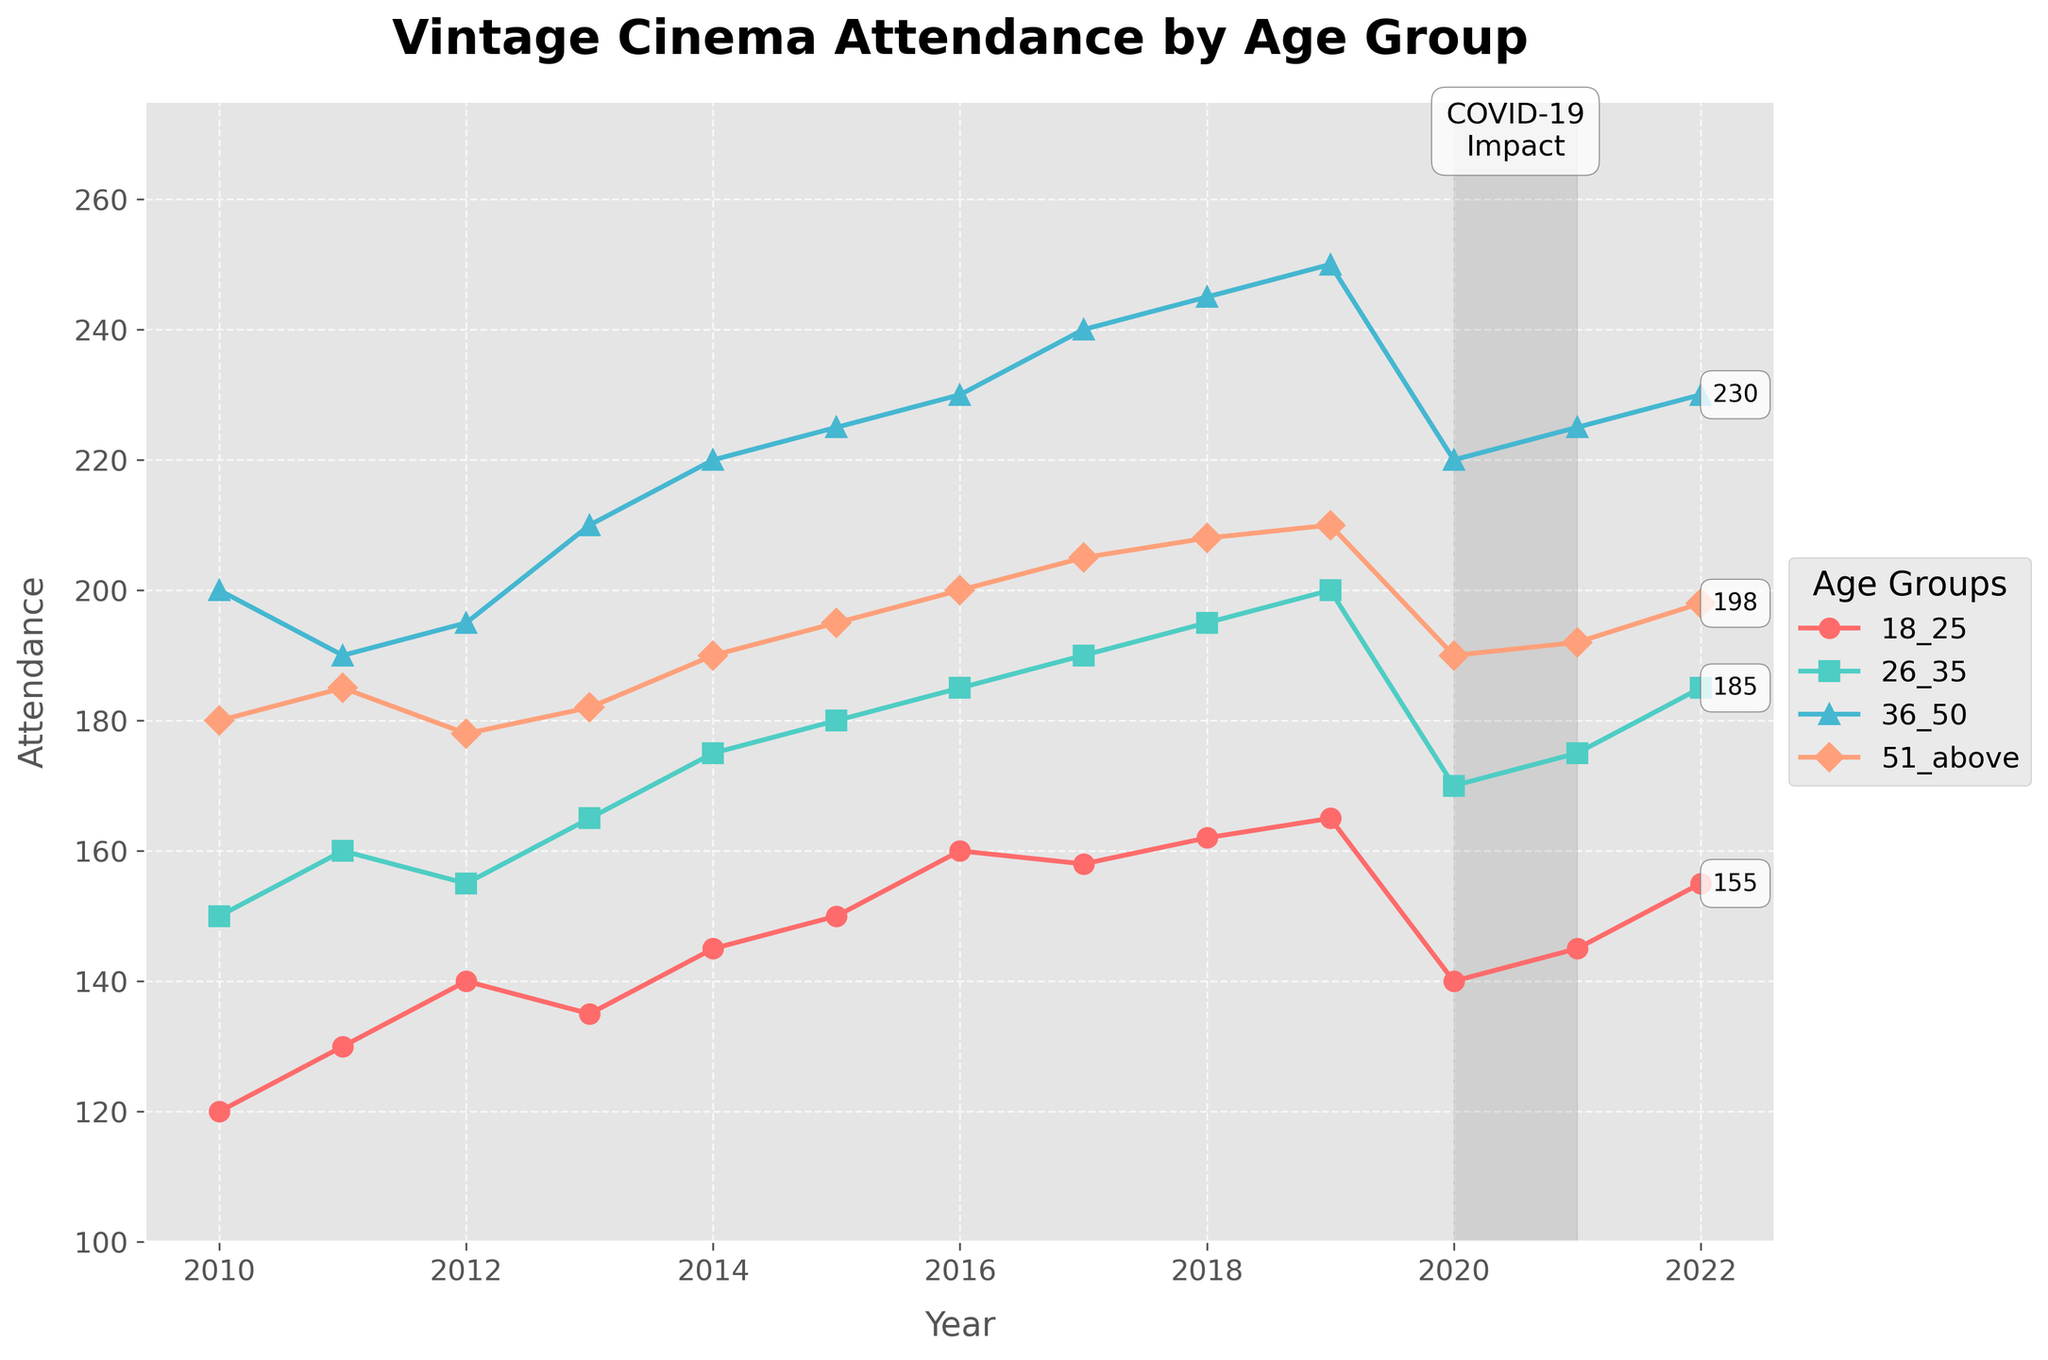What is the title of the plot? The title can be found at the top center of the plot. It gives an overview of the data being represented.
Answer: Vintage Cinema Attendance by Age Group Which age group has the highest attendance in 2019? Locate the data points for the year 2019 on the x-axis, and check which line reaches the highest vertical point.
Answer: Age Group 36-50 What is the overall trend for the age group 26-35 from 2010 to 2022? Locate the data points for the age group 26-35 over the years. Observe if the line goes generally upward or downward.
Answer: Upward How was the attendance affected for all age groups during the COVID-19 impact period? Observe the highlighted area on the plot from 2020 to 2021 and how each line changes within that range.
Answer: Decreased Which age group had the lowest attendance in 2020, and what was the approximate value? Look at the year 2020 on the x-axis and check which line is the lowest vertically. Then, read the approximate value from the y-axis.
Answer: Age Group 18-25, 140 How many age groups surpassed an attendance of 200 in 2022? Find the year 2022 and check each line to see if it crosses the 200 mark on the y-axis. Count these age groups.
Answer: Three What is the difference in attendance between the age groups 36-50 and 51+ in 2022? Locate the year 2022 and find the endpoints of the lines for Age Group 36-50 and Age Group 51+. Subtract the smaller value from the larger value.
Answer: 32 During which years did the 18-25 age group see an increase in attendance? Trace the path of the 18-25 age group line year by year, noting where the line goes upward.
Answer: 2010-2012, 2014-2019, 2021-2022 Which age group shows the most fluctuations in attendance rate over the years? Observe all lines across the entire range of years and note which line has the most ups and downs.
Answer: Age Group 18-25 What was the attendance rate for the age group 26-35 in 2016? Find the year 2016 on the x-axis and look at the corresponding data point for Age Group 26-35 to read the value on the y-axis.
Answer: 185 